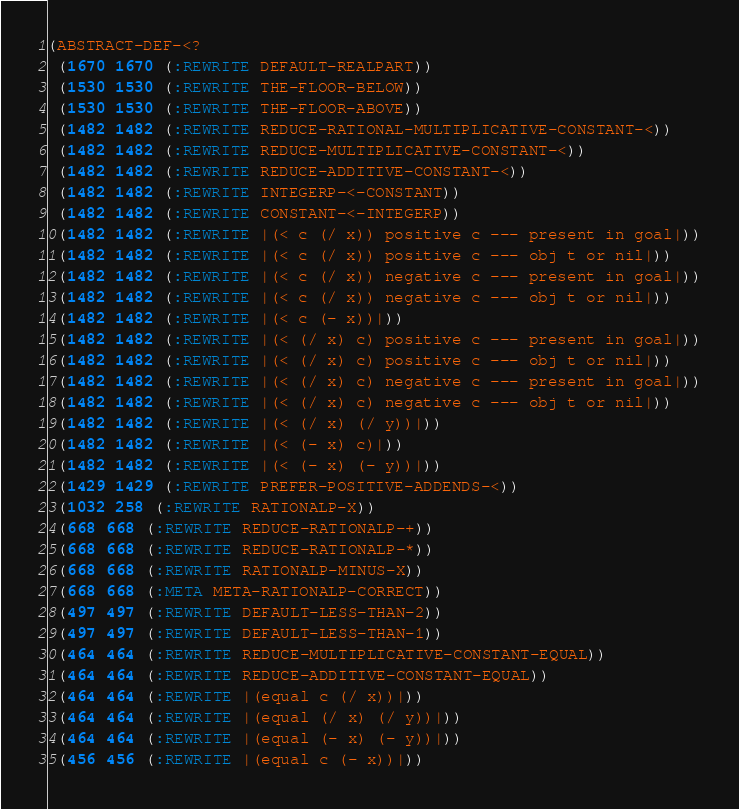Convert code to text. <code><loc_0><loc_0><loc_500><loc_500><_Lisp_>(ABSTRACT-DEF-<?
 (1670 1670 (:REWRITE DEFAULT-REALPART))
 (1530 1530 (:REWRITE THE-FLOOR-BELOW))
 (1530 1530 (:REWRITE THE-FLOOR-ABOVE))
 (1482 1482 (:REWRITE REDUCE-RATIONAL-MULTIPLICATIVE-CONSTANT-<))
 (1482 1482 (:REWRITE REDUCE-MULTIPLICATIVE-CONSTANT-<))
 (1482 1482 (:REWRITE REDUCE-ADDITIVE-CONSTANT-<))
 (1482 1482 (:REWRITE INTEGERP-<-CONSTANT))
 (1482 1482 (:REWRITE CONSTANT-<-INTEGERP))
 (1482 1482 (:REWRITE |(< c (/ x)) positive c --- present in goal|))
 (1482 1482 (:REWRITE |(< c (/ x)) positive c --- obj t or nil|))
 (1482 1482 (:REWRITE |(< c (/ x)) negative c --- present in goal|))
 (1482 1482 (:REWRITE |(< c (/ x)) negative c --- obj t or nil|))
 (1482 1482 (:REWRITE |(< c (- x))|))
 (1482 1482 (:REWRITE |(< (/ x) c) positive c --- present in goal|))
 (1482 1482 (:REWRITE |(< (/ x) c) positive c --- obj t or nil|))
 (1482 1482 (:REWRITE |(< (/ x) c) negative c --- present in goal|))
 (1482 1482 (:REWRITE |(< (/ x) c) negative c --- obj t or nil|))
 (1482 1482 (:REWRITE |(< (/ x) (/ y))|))
 (1482 1482 (:REWRITE |(< (- x) c)|))
 (1482 1482 (:REWRITE |(< (- x) (- y))|))
 (1429 1429 (:REWRITE PREFER-POSITIVE-ADDENDS-<))
 (1032 258 (:REWRITE RATIONALP-X))
 (668 668 (:REWRITE REDUCE-RATIONALP-+))
 (668 668 (:REWRITE REDUCE-RATIONALP-*))
 (668 668 (:REWRITE RATIONALP-MINUS-X))
 (668 668 (:META META-RATIONALP-CORRECT))
 (497 497 (:REWRITE DEFAULT-LESS-THAN-2))
 (497 497 (:REWRITE DEFAULT-LESS-THAN-1))
 (464 464 (:REWRITE REDUCE-MULTIPLICATIVE-CONSTANT-EQUAL))
 (464 464 (:REWRITE REDUCE-ADDITIVE-CONSTANT-EQUAL))
 (464 464 (:REWRITE |(equal c (/ x))|))
 (464 464 (:REWRITE |(equal (/ x) (/ y))|))
 (464 464 (:REWRITE |(equal (- x) (- y))|))
 (456 456 (:REWRITE |(equal c (- x))|))</code> 